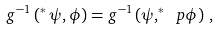Convert formula to latex. <formula><loc_0><loc_0><loc_500><loc_500>g ^ { - 1 } \left ( ^ { * } \, \psi , \phi \right ) = g ^ { - 1 } \left ( \psi , ^ { * } \ p \phi \right ) \, ,</formula> 